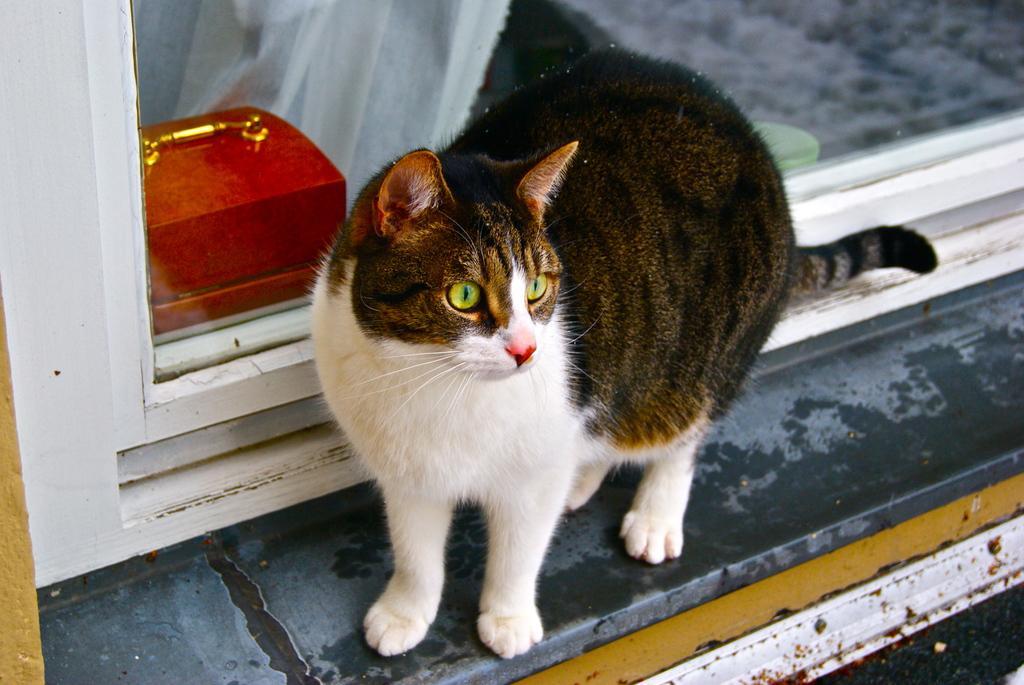Describe this image in one or two sentences. In this image, we can see a cat at the window and through the window, we can see a box. 